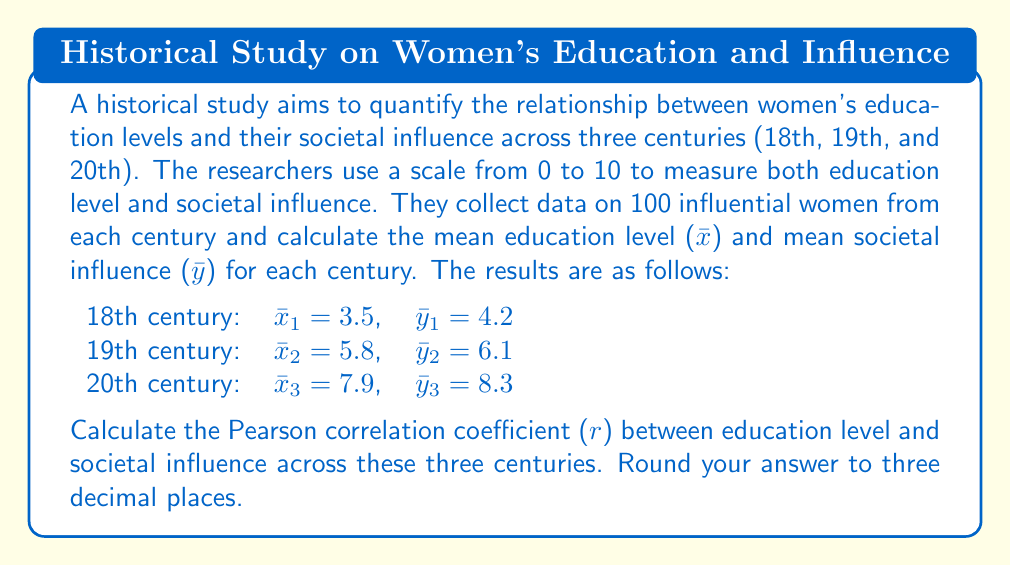What is the answer to this math problem? To calculate the Pearson correlation coefficient ($r$) between education level ($x$) and societal influence ($y$) across the three centuries, we'll use the formula:

$$ r = \frac{\sum_{i=1}^{n} (x_i - \bar{x})(y_i - \bar{y})}{\sqrt{\sum_{i=1}^{n} (x_i - \bar{x})^2 \sum_{i=1}^{n} (y_i - \bar{y})^2}} $$

Where $n = 3$ (number of centuries), $x_i$ and $y_i$ are the mean education level and societal influence for each century, respectively.

Step 1: Calculate the overall means $\bar{x}$ and $\bar{y}$:
$\bar{x} = \frac{3.5 + 5.8 + 7.9}{3} = 5.73$
$\bar{y} = \frac{4.2 + 6.1 + 8.3}{3} = 6.20$

Step 2: Calculate $(x_i - \bar{x})$ and $(y_i - \bar{y})$ for each century:
18th: $(3.5 - 5.73) = -2.23$, $(4.2 - 6.20) = -2.00$
19th: $(5.8 - 5.73) = 0.07$, $(6.1 - 6.20) = -0.10$
20th: $(7.9 - 5.73) = 2.17$, $(8.3 - 6.20) = 2.10$

Step 3: Calculate the numerator $\sum_{i=1}^{n} (x_i - \bar{x})(y_i - \bar{y})$:
$(-2.23 \times -2.00) + (0.07 \times -0.10) + (2.17 \times 2.10) = 4.46 - 0.007 + 4.557 = 9.01$

Step 4: Calculate $\sum_{i=1}^{n} (x_i - \bar{x})^2$ and $\sum_{i=1}^{n} (y_i - \bar{y})^2$:
$\sum_{i=1}^{n} (x_i - \bar{x})^2 = (-2.23)^2 + (0.07)^2 + (2.17)^2 = 4.9729 + 0.0049 + 4.7089 = 9.6867$
$\sum_{i=1}^{n} (y_i - \bar{y})^2 = (-2.00)^2 + (-0.10)^2 + (2.10)^2 = 4.0000 + 0.0100 + 4.4100 = 8.4200$

Step 5: Calculate the denominator $\sqrt{\sum_{i=1}^{n} (x_i - \bar{x})^2 \sum_{i=1}^{n} (y_i - \bar{y})^2}$:
$\sqrt{9.6867 \times 8.4200} = \sqrt{81.5620} = 9.0312$

Step 6: Calculate $r$:
$r = \frac{9.01}{9.0312} = 0.9974$

Rounding to three decimal places, we get $r = 0.997$.
Answer: $r = 0.997$ 